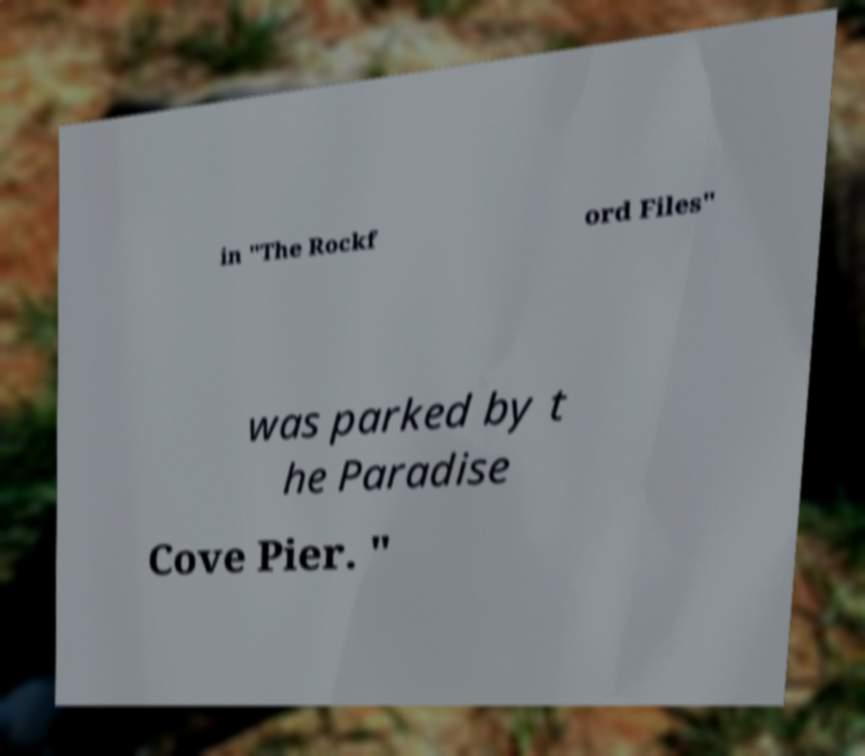Please read and relay the text visible in this image. What does it say? in "The Rockf ord Files" was parked by t he Paradise Cove Pier. " 